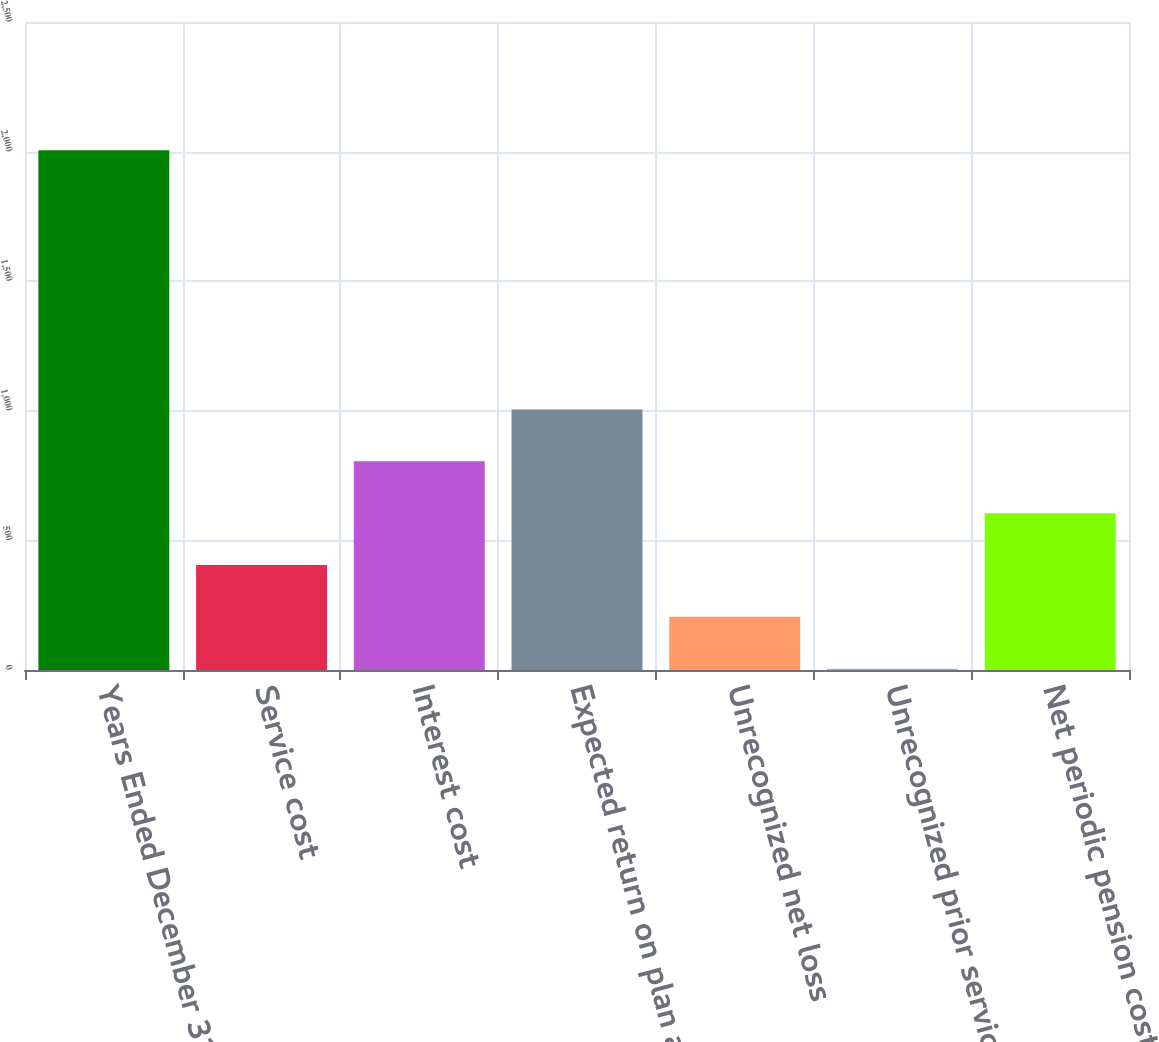Convert chart. <chart><loc_0><loc_0><loc_500><loc_500><bar_chart><fcel>Years Ended December 31<fcel>Service cost<fcel>Interest cost<fcel>Expected return on plan assets<fcel>Unrecognized net loss<fcel>Unrecognized prior service<fcel>Net periodic pension cost<nl><fcel>2005<fcel>405<fcel>805<fcel>1005<fcel>205<fcel>5<fcel>605<nl></chart> 